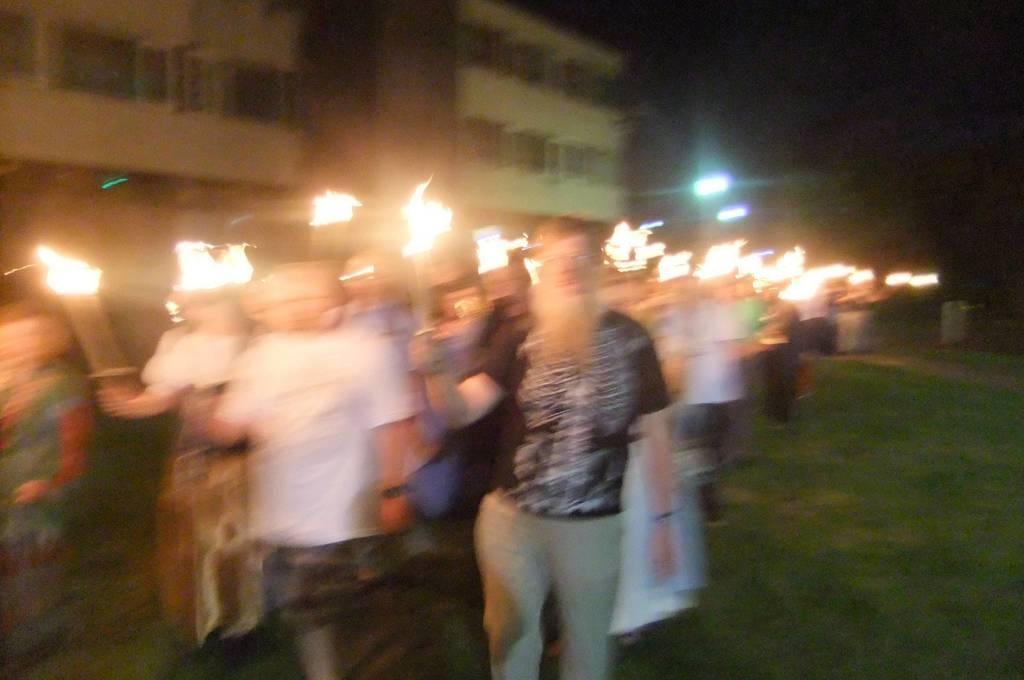What can be seen in the image? There is a group of men and women in the image. Where are the individuals located in the image? The group is standing in the front. What are the individuals holding in their hands? The individuals are holding fire sticks in their hands. What can be seen in the background of the image? There is a white building in the background of the image. What type of rest is the dad taking in the image? There is no dad or rest present in the image. What type of beam is supporting the white building in the image? The image does not show the details of the white building's structure, so it is not possible to determine the type of beam supporting it. 